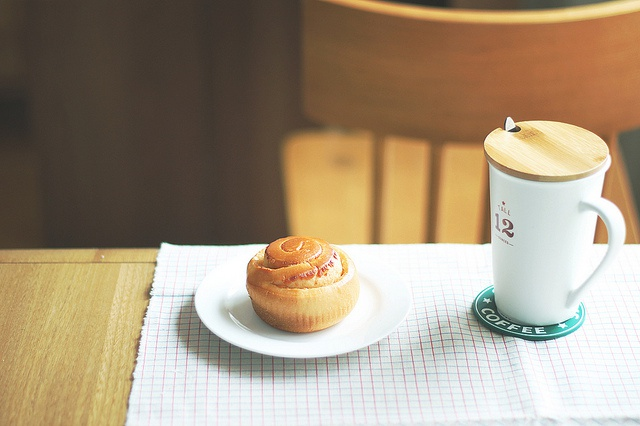Describe the objects in this image and their specific colors. I can see dining table in black, white, tan, and khaki tones, chair in black, tan, brown, and salmon tones, cup in black, lightgray, khaki, darkgray, and lightblue tones, and cake in black, orange, khaki, ivory, and brown tones in this image. 